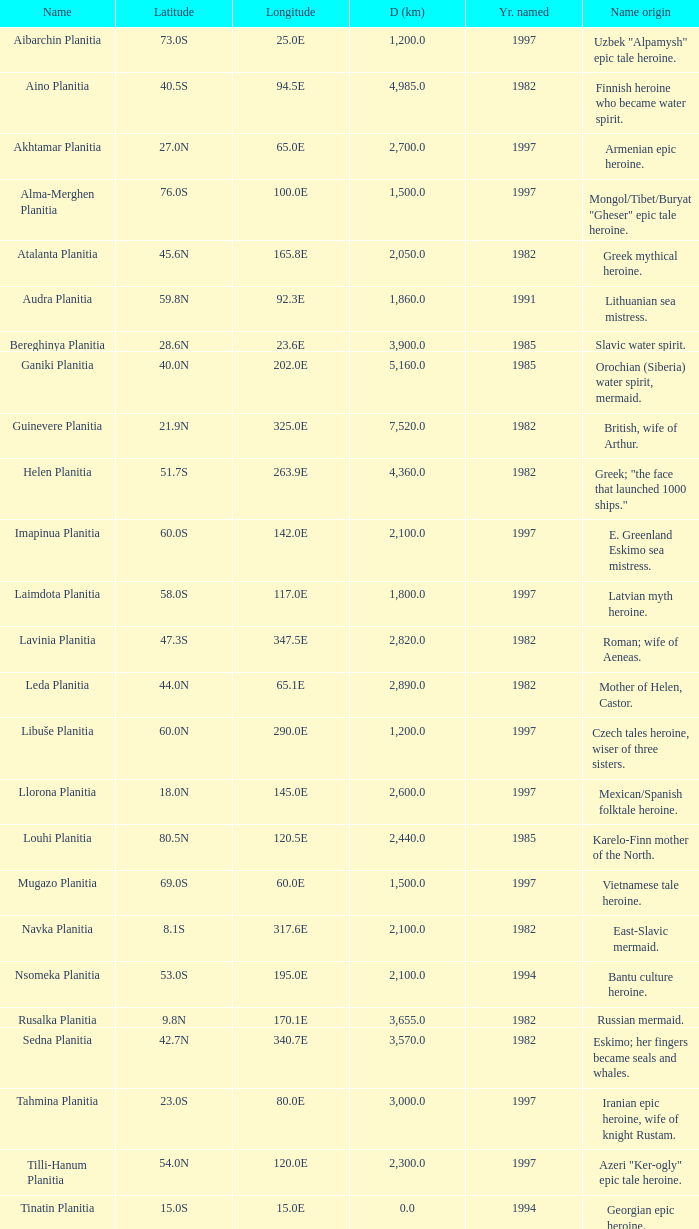What is the diameter (km) of the feature of latitude 23.0s 3000.0. 